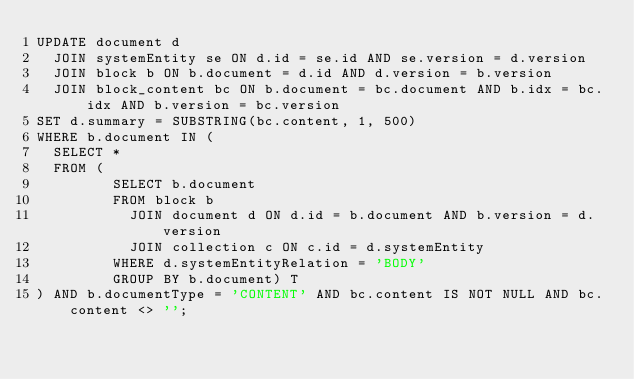<code> <loc_0><loc_0><loc_500><loc_500><_SQL_>UPDATE document d
  JOIN systemEntity se ON d.id = se.id AND se.version = d.version
  JOIN block b ON b.document = d.id AND d.version = b.version
  JOIN block_content bc ON b.document = bc.document AND b.idx = bc.idx AND b.version = bc.version
SET d.summary = SUBSTRING(bc.content, 1, 500)
WHERE b.document IN (
  SELECT *
  FROM (
         SELECT b.document
         FROM block b
           JOIN document d ON d.id = b.document AND b.version = d.version
           JOIN collection c ON c.id = d.systemEntity
         WHERE d.systemEntityRelation = 'BODY'
         GROUP BY b.document) T
) AND b.documentType = 'CONTENT' AND bc.content IS NOT NULL AND bc.content <> '';
</code> 